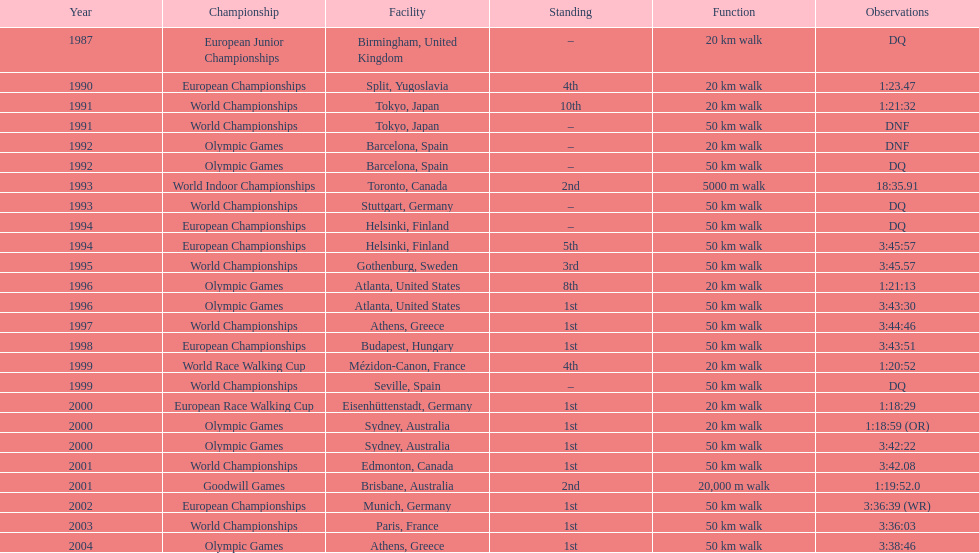How many times was first place listed as the position? 10. 